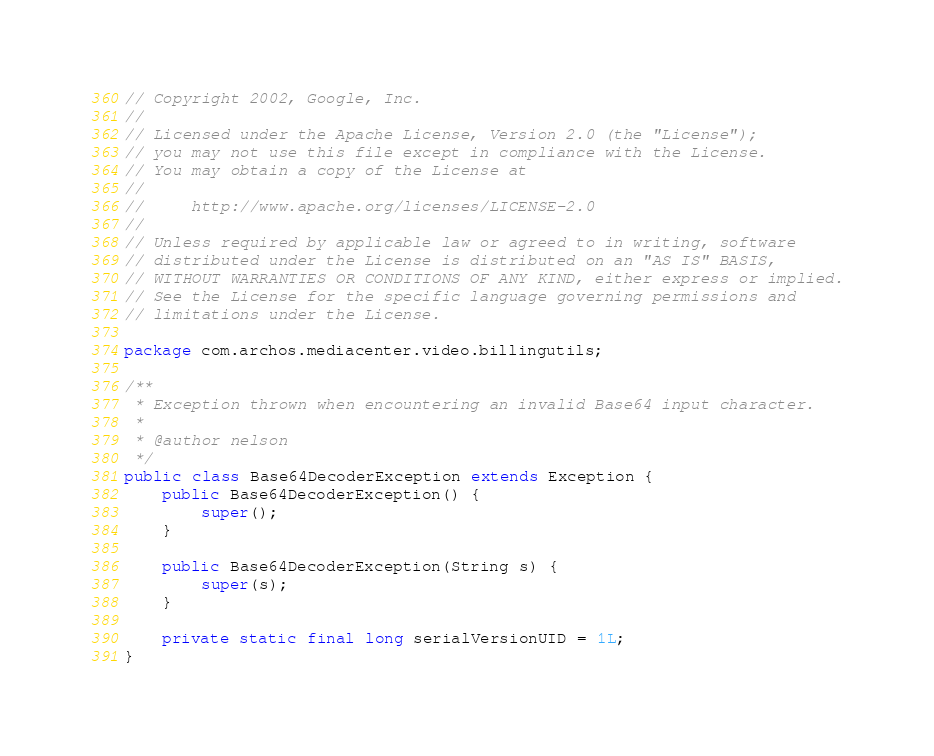Convert code to text. <code><loc_0><loc_0><loc_500><loc_500><_Java_>// Copyright 2002, Google, Inc.
//
// Licensed under the Apache License, Version 2.0 (the "License");
// you may not use this file except in compliance with the License.
// You may obtain a copy of the License at
//
//     http://www.apache.org/licenses/LICENSE-2.0
//
// Unless required by applicable law or agreed to in writing, software
// distributed under the License is distributed on an "AS IS" BASIS,
// WITHOUT WARRANTIES OR CONDITIONS OF ANY KIND, either express or implied.
// See the License for the specific language governing permissions and
// limitations under the License.

package com.archos.mediacenter.video.billingutils;

/**
 * Exception thrown when encountering an invalid Base64 input character.
 *
 * @author nelson
 */
public class Base64DecoderException extends Exception {
    public Base64DecoderException() {
        super();
    }

    public Base64DecoderException(String s) {
        super(s);
    }

    private static final long serialVersionUID = 1L;
}
</code> 